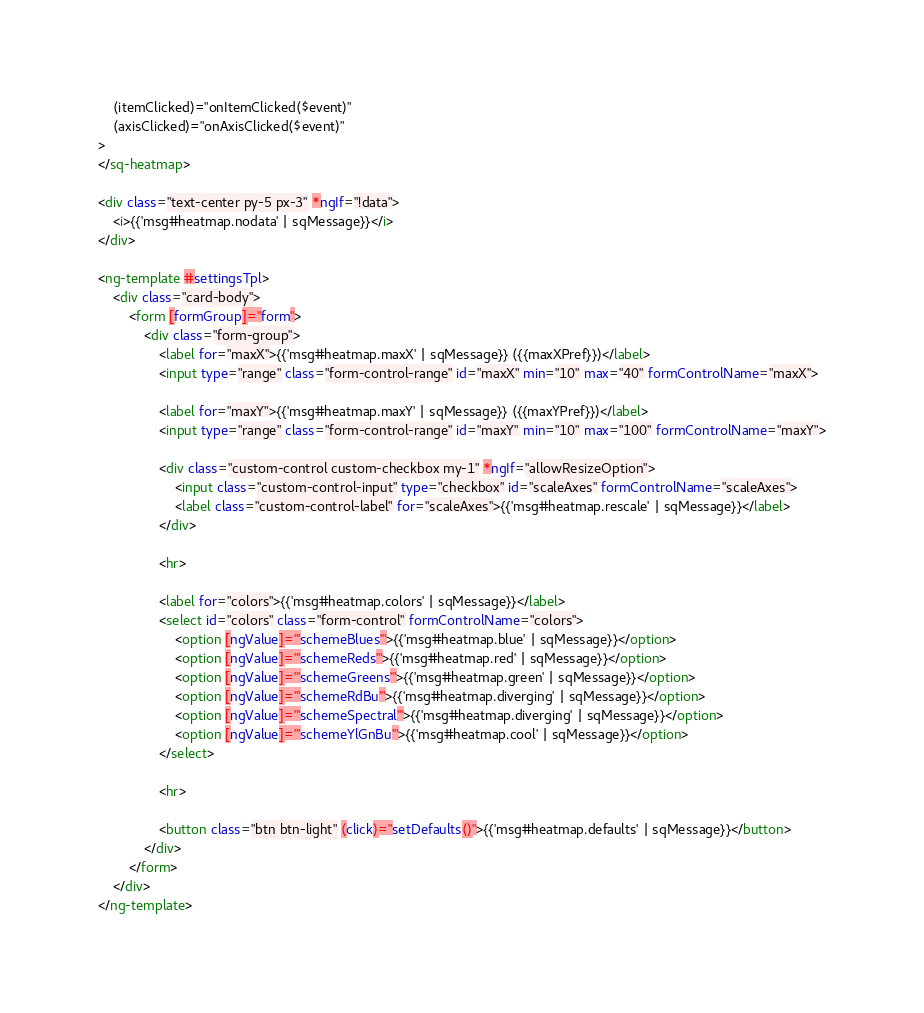<code> <loc_0><loc_0><loc_500><loc_500><_HTML_>
    (itemClicked)="onItemClicked($event)"
    (axisClicked)="onAxisClicked($event)"
>
</sq-heatmap>

<div class="text-center py-5 px-3" *ngIf="!data">
    <i>{{'msg#heatmap.nodata' | sqMessage}}</i>
</div>

<ng-template #settingsTpl>
    <div class="card-body">
        <form [formGroup]="form">
            <div class="form-group">
                <label for="maxX">{{'msg#heatmap.maxX' | sqMessage}} ({{maxXPref}})</label>
                <input type="range" class="form-control-range" id="maxX" min="10" max="40" formControlName="maxX">

                <label for="maxY">{{'msg#heatmap.maxY' | sqMessage}} ({{maxYPref}})</label>
                <input type="range" class="form-control-range" id="maxY" min="10" max="100" formControlName="maxY">
                
                <div class="custom-control custom-checkbox my-1" *ngIf="allowResizeOption">
                    <input class="custom-control-input" type="checkbox" id="scaleAxes" formControlName="scaleAxes">
                    <label class="custom-control-label" for="scaleAxes">{{'msg#heatmap.rescale' | sqMessage}}</label>
                </div>

                <hr>

                <label for="colors">{{'msg#heatmap.colors' | sqMessage}}</label>
                <select id="colors" class="form-control" formControlName="colors">
                    <option [ngValue]="'schemeBlues'">{{'msg#heatmap.blue' | sqMessage}}</option>
                    <option [ngValue]="'schemeReds'">{{'msg#heatmap.red' | sqMessage}}</option>
                    <option [ngValue]="'schemeGreens'">{{'msg#heatmap.green' | sqMessage}}</option>
                    <option [ngValue]="'schemeRdBu'">{{'msg#heatmap.diverging' | sqMessage}}</option>
                    <option [ngValue]="'schemeSpectral'">{{'msg#heatmap.diverging' | sqMessage}}</option>
                    <option [ngValue]="'schemeYlGnBu'">{{'msg#heatmap.cool' | sqMessage}}</option>
                </select>

                <hr>

                <button class="btn btn-light" (click)="setDefaults()">{{'msg#heatmap.defaults' | sqMessage}}</button>
            </div>
        </form>
    </div>
</ng-template></code> 